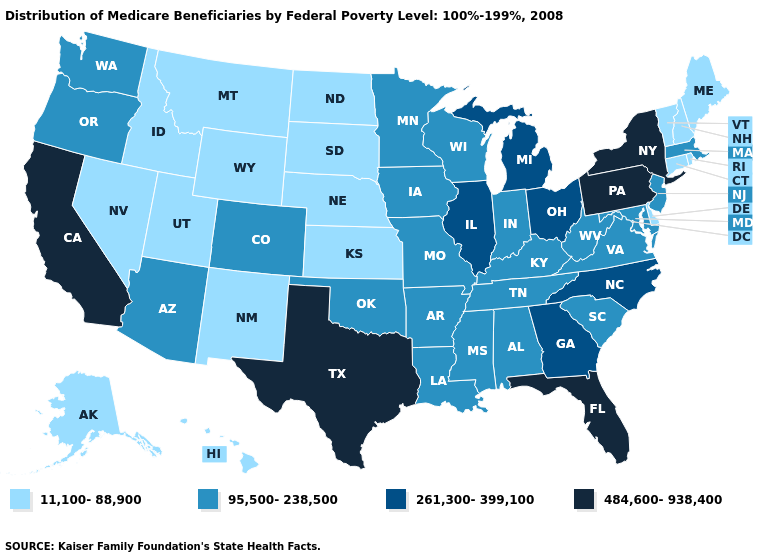Name the states that have a value in the range 11,100-88,900?
Concise answer only. Alaska, Connecticut, Delaware, Hawaii, Idaho, Kansas, Maine, Montana, Nebraska, Nevada, New Hampshire, New Mexico, North Dakota, Rhode Island, South Dakota, Utah, Vermont, Wyoming. Among the states that border Kansas , does Nebraska have the lowest value?
Give a very brief answer. Yes. Does the map have missing data?
Quick response, please. No. What is the lowest value in the South?
Short answer required. 11,100-88,900. Which states have the lowest value in the USA?
Concise answer only. Alaska, Connecticut, Delaware, Hawaii, Idaho, Kansas, Maine, Montana, Nebraska, Nevada, New Hampshire, New Mexico, North Dakota, Rhode Island, South Dakota, Utah, Vermont, Wyoming. Name the states that have a value in the range 261,300-399,100?
Give a very brief answer. Georgia, Illinois, Michigan, North Carolina, Ohio. Which states have the highest value in the USA?
Concise answer only. California, Florida, New York, Pennsylvania, Texas. How many symbols are there in the legend?
Answer briefly. 4. How many symbols are there in the legend?
Write a very short answer. 4. What is the lowest value in the West?
Keep it brief. 11,100-88,900. What is the value of Alabama?
Give a very brief answer. 95,500-238,500. Does the map have missing data?
Be succinct. No. Does Arkansas have a higher value than Florida?
Concise answer only. No. Which states have the highest value in the USA?
Be succinct. California, Florida, New York, Pennsylvania, Texas. What is the lowest value in the South?
Short answer required. 11,100-88,900. 